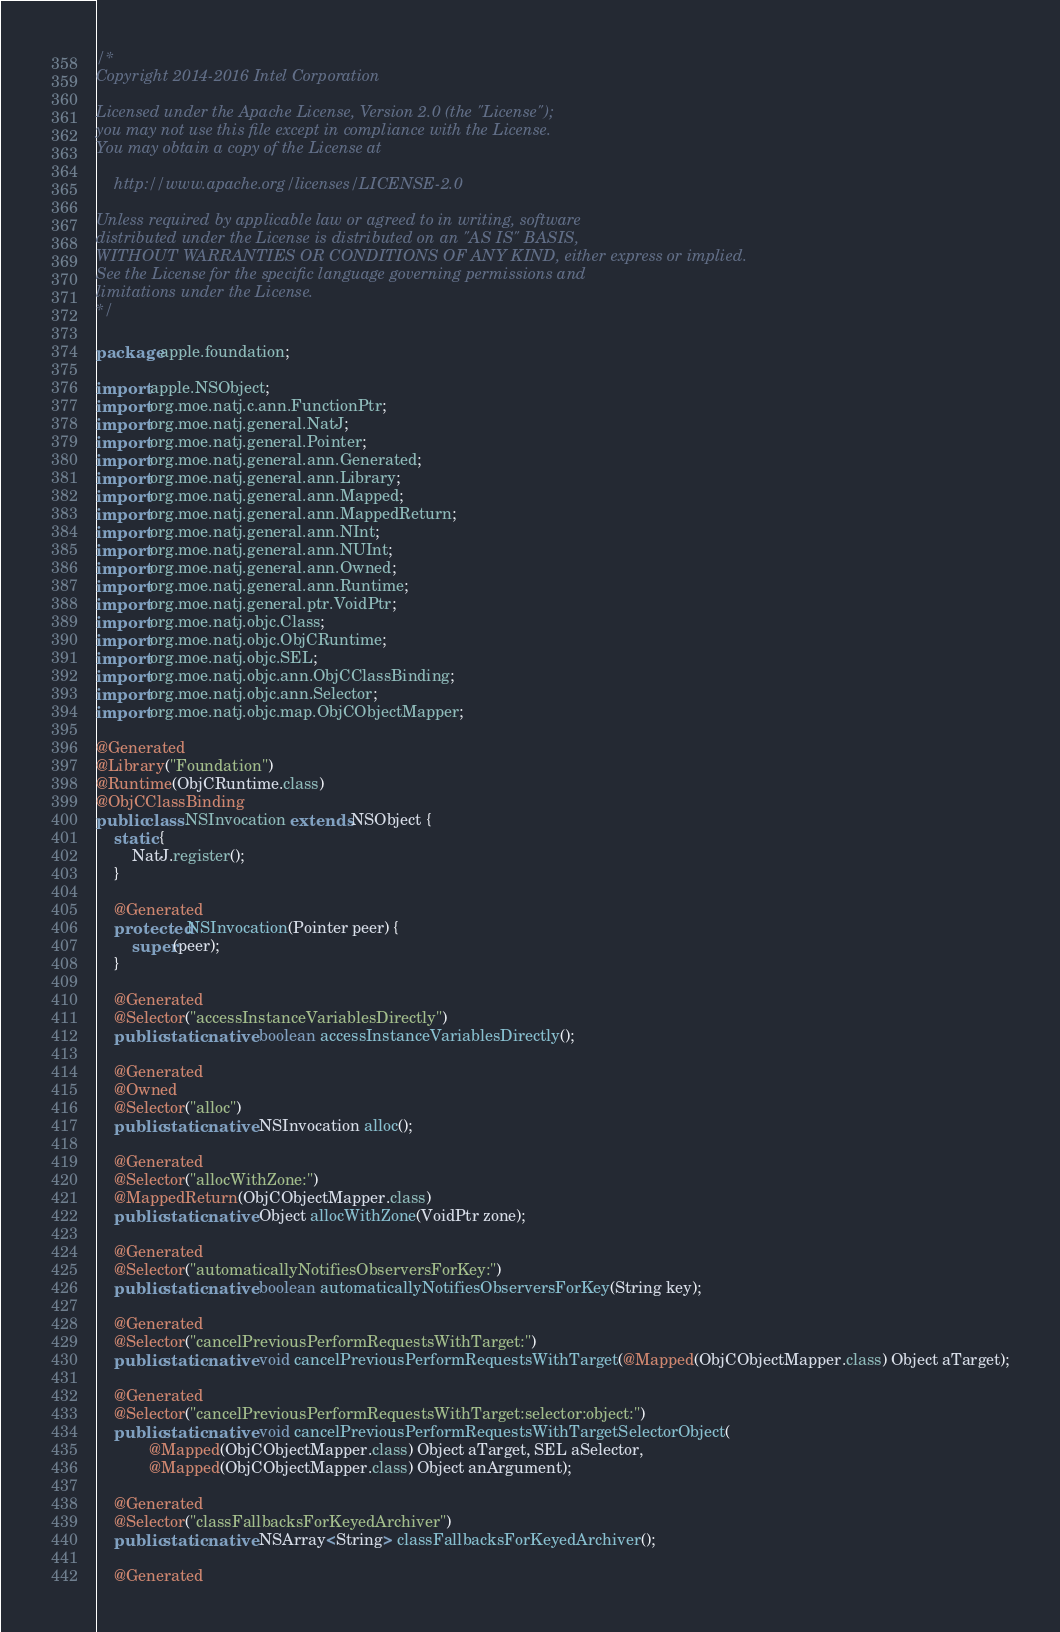<code> <loc_0><loc_0><loc_500><loc_500><_Java_>/*
Copyright 2014-2016 Intel Corporation

Licensed under the Apache License, Version 2.0 (the "License");
you may not use this file except in compliance with the License.
You may obtain a copy of the License at

    http://www.apache.org/licenses/LICENSE-2.0

Unless required by applicable law or agreed to in writing, software
distributed under the License is distributed on an "AS IS" BASIS,
WITHOUT WARRANTIES OR CONDITIONS OF ANY KIND, either express or implied.
See the License for the specific language governing permissions and
limitations under the License.
*/

package apple.foundation;

import apple.NSObject;
import org.moe.natj.c.ann.FunctionPtr;
import org.moe.natj.general.NatJ;
import org.moe.natj.general.Pointer;
import org.moe.natj.general.ann.Generated;
import org.moe.natj.general.ann.Library;
import org.moe.natj.general.ann.Mapped;
import org.moe.natj.general.ann.MappedReturn;
import org.moe.natj.general.ann.NInt;
import org.moe.natj.general.ann.NUInt;
import org.moe.natj.general.ann.Owned;
import org.moe.natj.general.ann.Runtime;
import org.moe.natj.general.ptr.VoidPtr;
import org.moe.natj.objc.Class;
import org.moe.natj.objc.ObjCRuntime;
import org.moe.natj.objc.SEL;
import org.moe.natj.objc.ann.ObjCClassBinding;
import org.moe.natj.objc.ann.Selector;
import org.moe.natj.objc.map.ObjCObjectMapper;

@Generated
@Library("Foundation")
@Runtime(ObjCRuntime.class)
@ObjCClassBinding
public class NSInvocation extends NSObject {
    static {
        NatJ.register();
    }

    @Generated
    protected NSInvocation(Pointer peer) {
        super(peer);
    }

    @Generated
    @Selector("accessInstanceVariablesDirectly")
    public static native boolean accessInstanceVariablesDirectly();

    @Generated
    @Owned
    @Selector("alloc")
    public static native NSInvocation alloc();

    @Generated
    @Selector("allocWithZone:")
    @MappedReturn(ObjCObjectMapper.class)
    public static native Object allocWithZone(VoidPtr zone);

    @Generated
    @Selector("automaticallyNotifiesObserversForKey:")
    public static native boolean automaticallyNotifiesObserversForKey(String key);

    @Generated
    @Selector("cancelPreviousPerformRequestsWithTarget:")
    public static native void cancelPreviousPerformRequestsWithTarget(@Mapped(ObjCObjectMapper.class) Object aTarget);

    @Generated
    @Selector("cancelPreviousPerformRequestsWithTarget:selector:object:")
    public static native void cancelPreviousPerformRequestsWithTargetSelectorObject(
            @Mapped(ObjCObjectMapper.class) Object aTarget, SEL aSelector,
            @Mapped(ObjCObjectMapper.class) Object anArgument);

    @Generated
    @Selector("classFallbacksForKeyedArchiver")
    public static native NSArray<String> classFallbacksForKeyedArchiver();

    @Generated</code> 